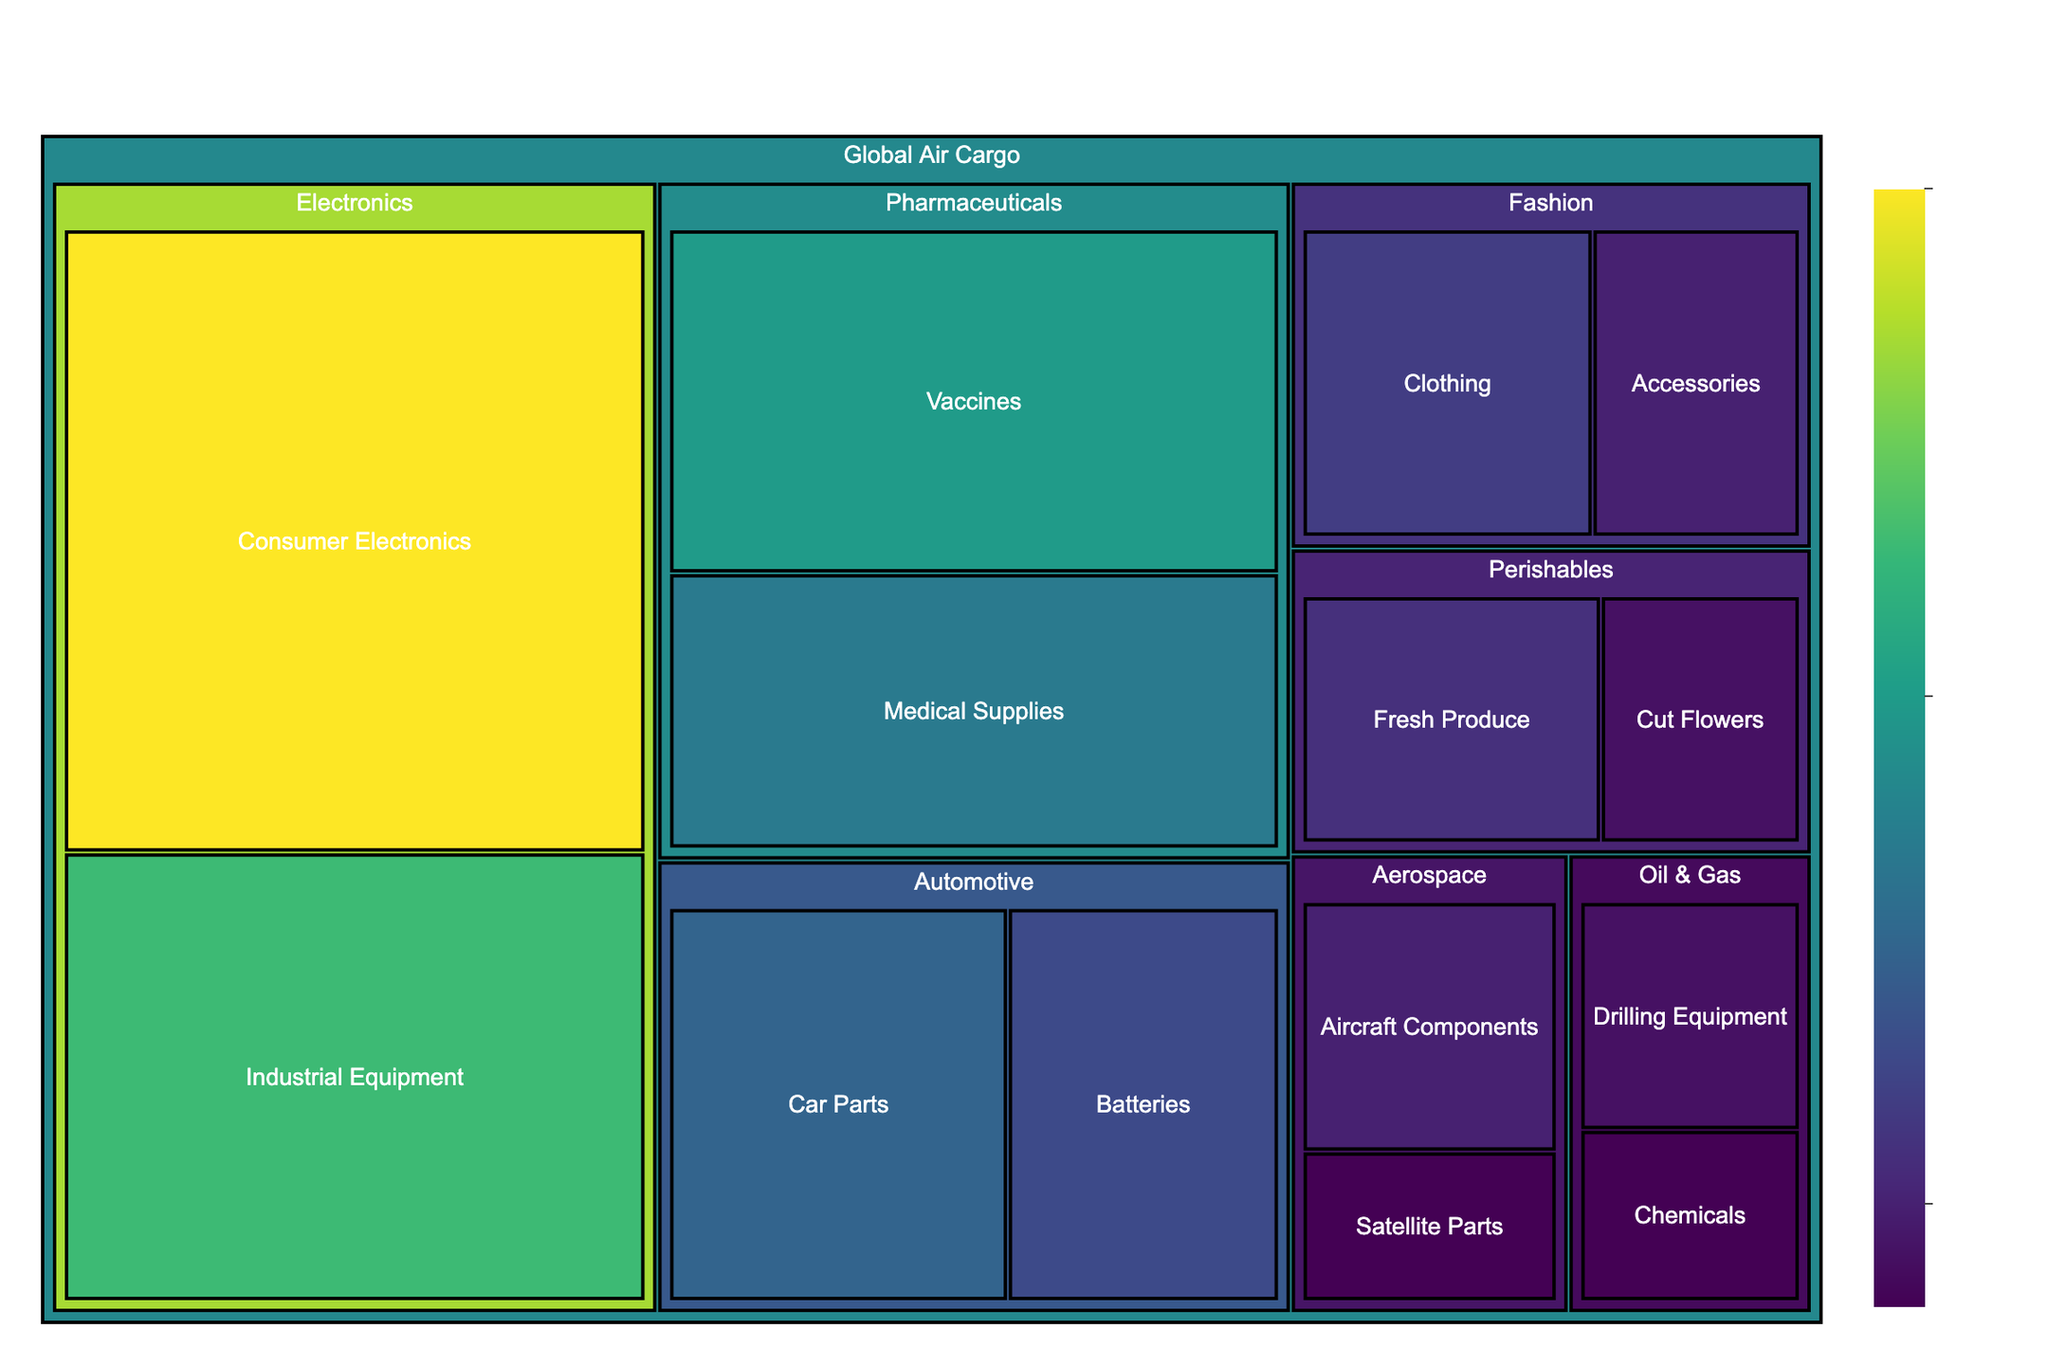What's the title of the Treemap? The title of the Treemap is usually displayed prominently at the top center of the plot. In this case, it's specifically mentioned in the code as 'Global Air Cargo Composition by Industry Sectors'.
Answer: Global Air Cargo Composition by Industry Sectors Which category has the largest value within the Electronics industry? Within the Treemap, look for the Electronics industry section and identify the category with the largest value, which is indicated by the size of the segments. Consumer Electronics has a value of 25, which is the largest.
Answer: Consumer Electronics How many industry sectors are there in the Treemap? Count the different parent categories under "Global Air Cargo." The unique values from the data tell us there are Electronics, Pharmaceuticals, Automotive, Fashion, Perishables, Aerospace, and Oil & Gas.
Answer: 7 What is the combined value of the Automotive industry categories? Add the values for Car Parts and Batteries under the Automotive industry. Car Parts (10) + Batteries (8) = 18.
Answer: 18 Which category in the Pharmaceuticals industry has a higher value? Compare the values of Vaccines and Medical Supplies within the Pharmaceuticals industry. Vaccines have a value of 15, and Medical Supplies have a value of 12. Vaccines are higher.
Answer: Vaccines What is the smallest value category in the Aerospace industry? Look at the Aerospace industry and compare the values of Aircraft Components and Satellite Parts. Satellite Parts have the smallest value of 3.
Answer: Satellite Parts How does the value of Fresh Produce in Perishables compare to Cut Flowers in Perishables? Compare the values of Fresh Produce and Cut Flowers within the Perishables industry. Fresh Produce has a value of 6, whereas Cut Flowers have a value of 4. Fresh Produce is higher.
Answer: Fresh Produce is higher What is the total value of all categories in the Perishables industry? Add the values of Fresh Produce and Cut Flowers within the Perishables industry. Fresh Produce (6) + Cut Flowers (4) = 10.
Answer: 10 Which has a greater value, Industrial Equipment in Electronics or Car Parts in Automotive? Compare the values of Industrial Equipment in Electronics and Car Parts in Automotive. Industrial Equipment in Electronics has a value of 18, and Car Parts in Automotive has a value of 10. Industrial Equipment is greater.
Answer: Industrial Equipment in Electronics 